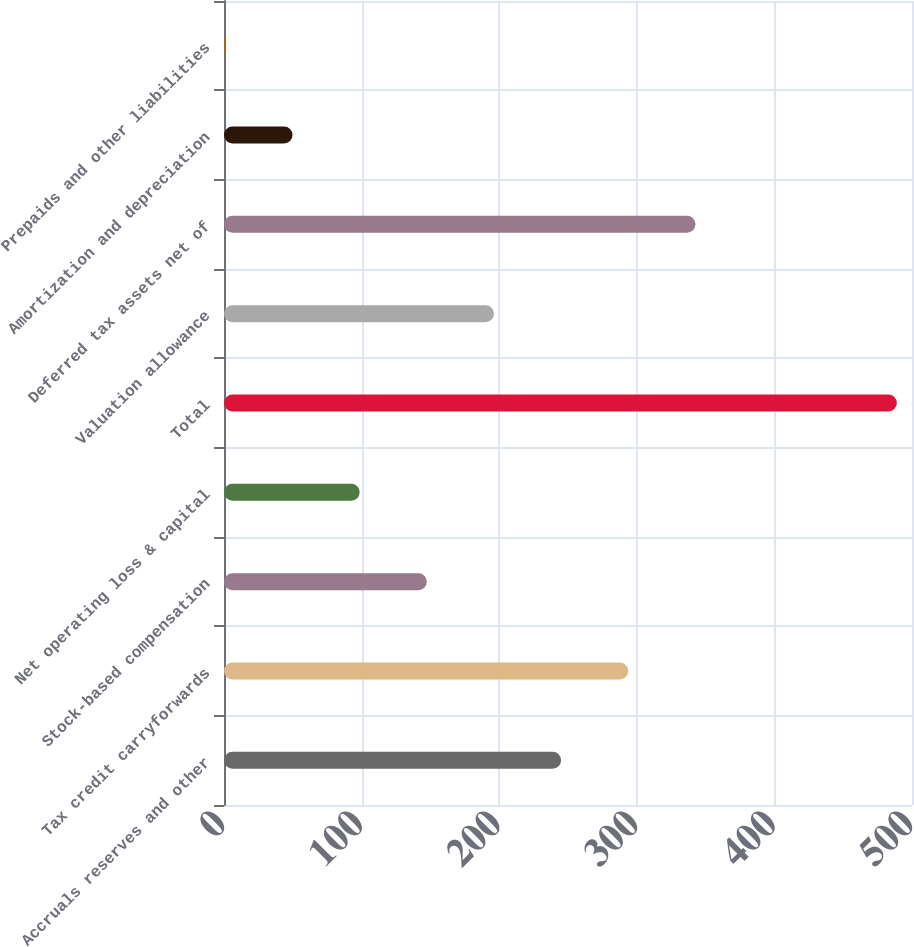<chart> <loc_0><loc_0><loc_500><loc_500><bar_chart><fcel>Accruals reserves and other<fcel>Tax credit carryforwards<fcel>Stock-based compensation<fcel>Net operating loss & capital<fcel>Total<fcel>Valuation allowance<fcel>Deferred tax assets net of<fcel>Amortization and depreciation<fcel>Prepaids and other liabilities<nl><fcel>245<fcel>293.8<fcel>147.4<fcel>98.6<fcel>489<fcel>196.2<fcel>342.6<fcel>49.8<fcel>1<nl></chart> 